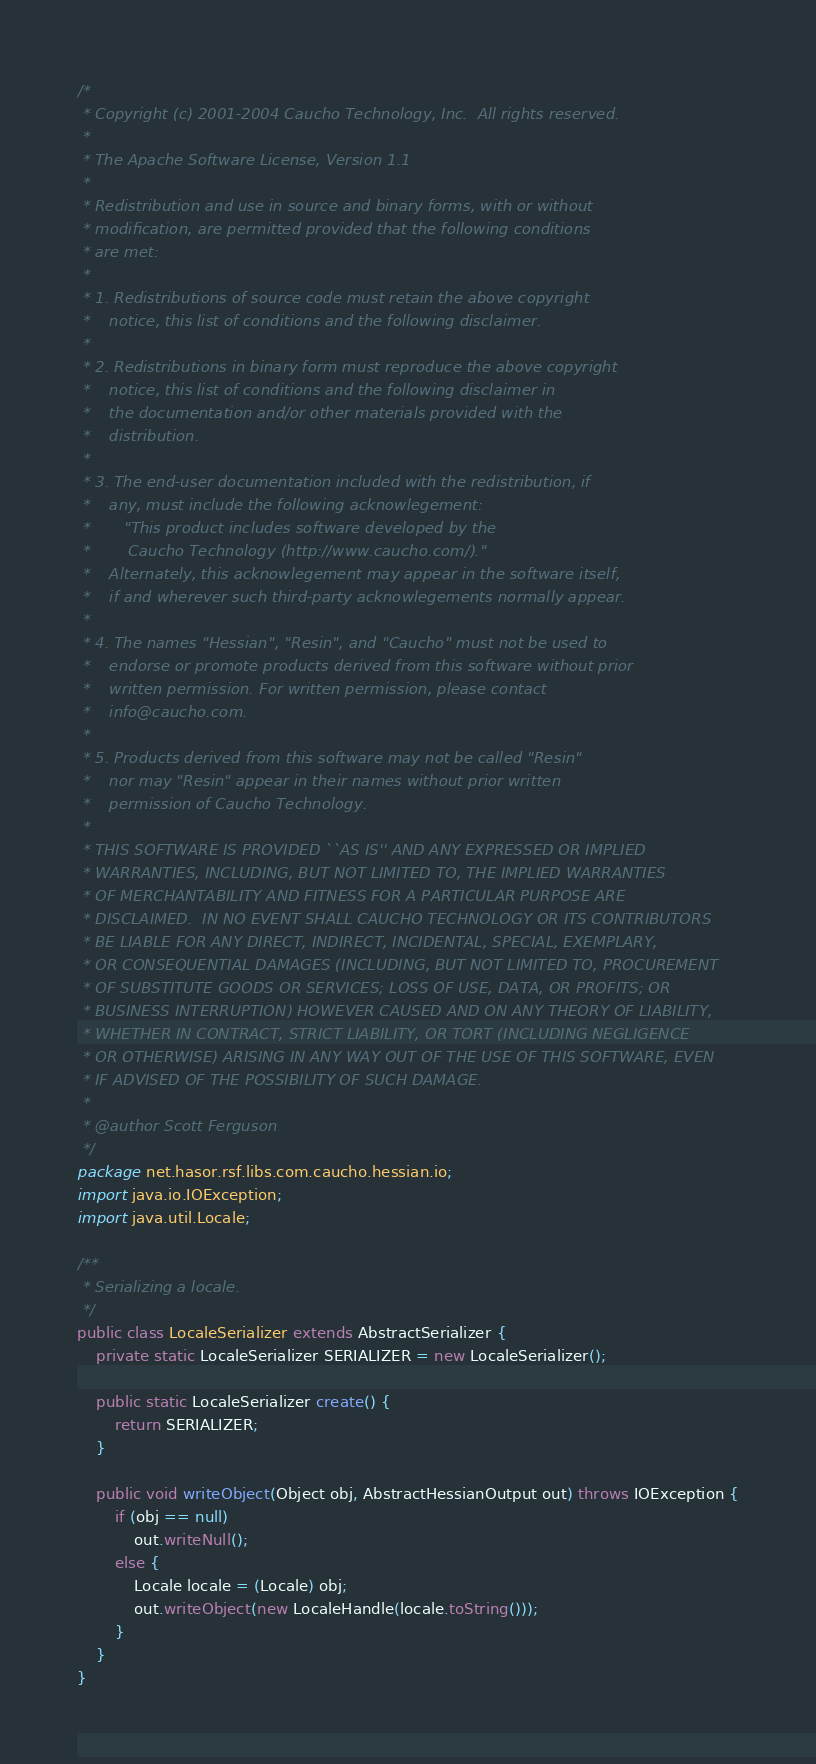<code> <loc_0><loc_0><loc_500><loc_500><_Java_>/*
 * Copyright (c) 2001-2004 Caucho Technology, Inc.  All rights reserved.
 *
 * The Apache Software License, Version 1.1
 *
 * Redistribution and use in source and binary forms, with or without
 * modification, are permitted provided that the following conditions
 * are met:
 *
 * 1. Redistributions of source code must retain the above copyright
 *    notice, this list of conditions and the following disclaimer.
 *
 * 2. Redistributions in binary form must reproduce the above copyright
 *    notice, this list of conditions and the following disclaimer in
 *    the documentation and/or other materials provided with the
 *    distribution.
 *
 * 3. The end-user documentation included with the redistribution, if
 *    any, must include the following acknowlegement:
 *       "This product includes software developed by the
 *        Caucho Technology (http://www.caucho.com/)."
 *    Alternately, this acknowlegement may appear in the software itself,
 *    if and wherever such third-party acknowlegements normally appear.
 *
 * 4. The names "Hessian", "Resin", and "Caucho" must not be used to
 *    endorse or promote products derived from this software without prior
 *    written permission. For written permission, please contact
 *    info@caucho.com.
 *
 * 5. Products derived from this software may not be called "Resin"
 *    nor may "Resin" appear in their names without prior written
 *    permission of Caucho Technology.
 *
 * THIS SOFTWARE IS PROVIDED ``AS IS'' AND ANY EXPRESSED OR IMPLIED
 * WARRANTIES, INCLUDING, BUT NOT LIMITED TO, THE IMPLIED WARRANTIES
 * OF MERCHANTABILITY AND FITNESS FOR A PARTICULAR PURPOSE ARE
 * DISCLAIMED.  IN NO EVENT SHALL CAUCHO TECHNOLOGY OR ITS CONTRIBUTORS
 * BE LIABLE FOR ANY DIRECT, INDIRECT, INCIDENTAL, SPECIAL, EXEMPLARY,
 * OR CONSEQUENTIAL DAMAGES (INCLUDING, BUT NOT LIMITED TO, PROCUREMENT
 * OF SUBSTITUTE GOODS OR SERVICES; LOSS OF USE, DATA, OR PROFITS; OR
 * BUSINESS INTERRUPTION) HOWEVER CAUSED AND ON ANY THEORY OF LIABILITY,
 * WHETHER IN CONTRACT, STRICT LIABILITY, OR TORT (INCLUDING NEGLIGENCE
 * OR OTHERWISE) ARISING IN ANY WAY OUT OF THE USE OF THIS SOFTWARE, EVEN
 * IF ADVISED OF THE POSSIBILITY OF SUCH DAMAGE.
 *
 * @author Scott Ferguson
 */
package net.hasor.rsf.libs.com.caucho.hessian.io;
import java.io.IOException;
import java.util.Locale;

/**
 * Serializing a locale.
 */
public class LocaleSerializer extends AbstractSerializer {
    private static LocaleSerializer SERIALIZER = new LocaleSerializer();

    public static LocaleSerializer create() {
        return SERIALIZER;
    }

    public void writeObject(Object obj, AbstractHessianOutput out) throws IOException {
        if (obj == null)
            out.writeNull();
        else {
            Locale locale = (Locale) obj;
            out.writeObject(new LocaleHandle(locale.toString()));
        }
    }
}
</code> 